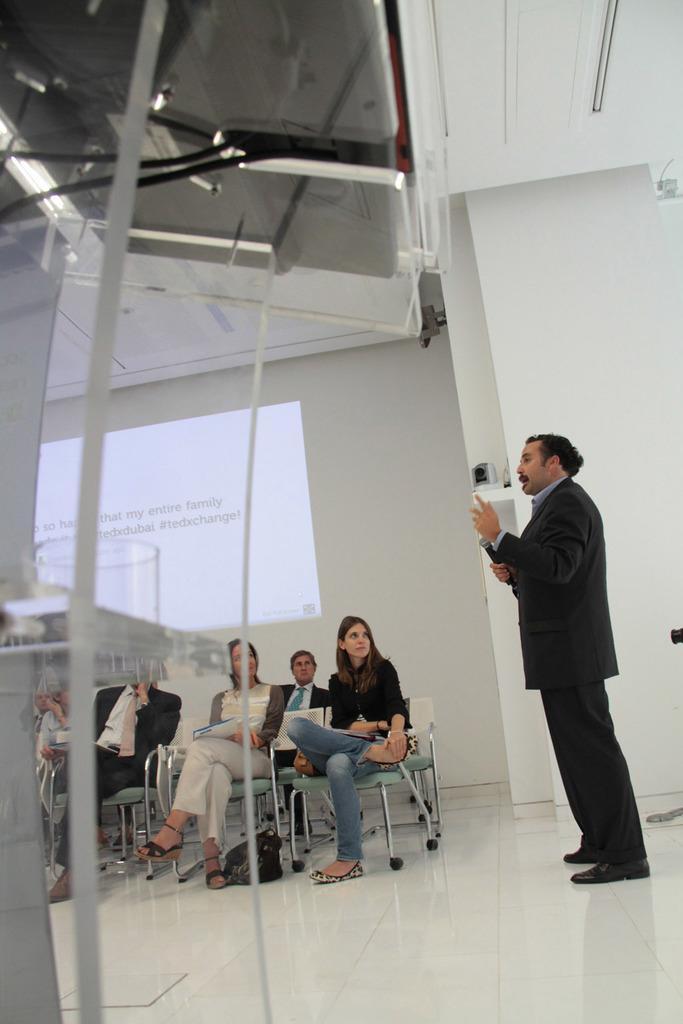How would you summarize this image in a sentence or two? In this picture we can see a group of people sitting on chairs and a man is standing on the floor and explaining something. He is holding a microphone in hand. On the left side of the image, there is an object and cables. Behind the people there is a projection on the wall 